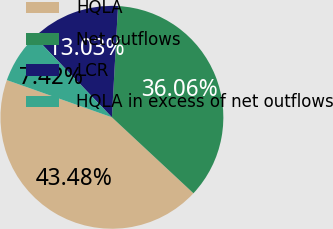Convert chart to OTSL. <chart><loc_0><loc_0><loc_500><loc_500><pie_chart><fcel>HQLA<fcel>Net outflows<fcel>LCR<fcel>HQLA in excess of net outflows<nl><fcel>43.48%<fcel>36.06%<fcel>13.03%<fcel>7.42%<nl></chart> 